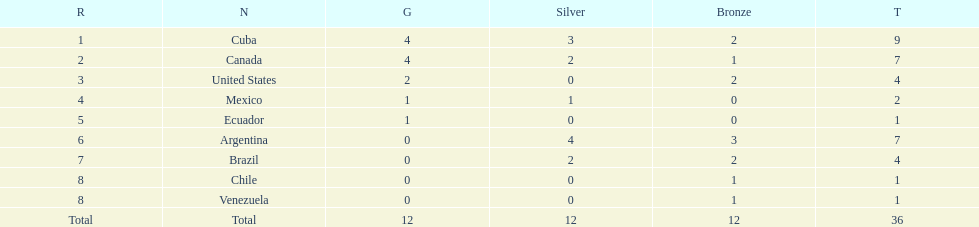Who had more silver medals, cuba or brazil? Cuba. 